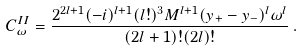<formula> <loc_0><loc_0><loc_500><loc_500>C _ { \omega } ^ { I I } = \frac { 2 ^ { 2 l + 1 } ( - i ) ^ { l + 1 } ( l ! ) ^ { 3 } M ^ { l + 1 } ( y _ { + } - y _ { - } ) ^ { l } \omega ^ { l } } { ( 2 l + 1 ) ! ( 2 l ) ! } \, .</formula> 